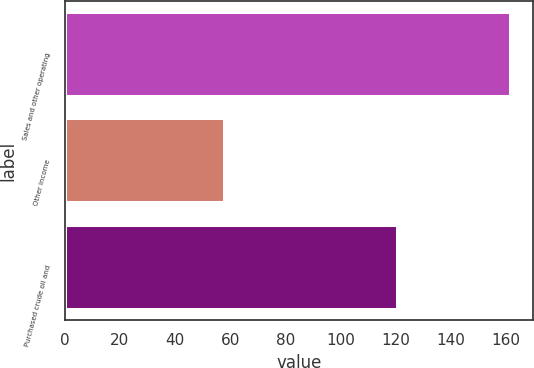Convert chart. <chart><loc_0><loc_0><loc_500><loc_500><bar_chart><fcel>Sales and other operating<fcel>Other income<fcel>Purchased crude oil and<nl><fcel>162<fcel>58<fcel>121<nl></chart> 